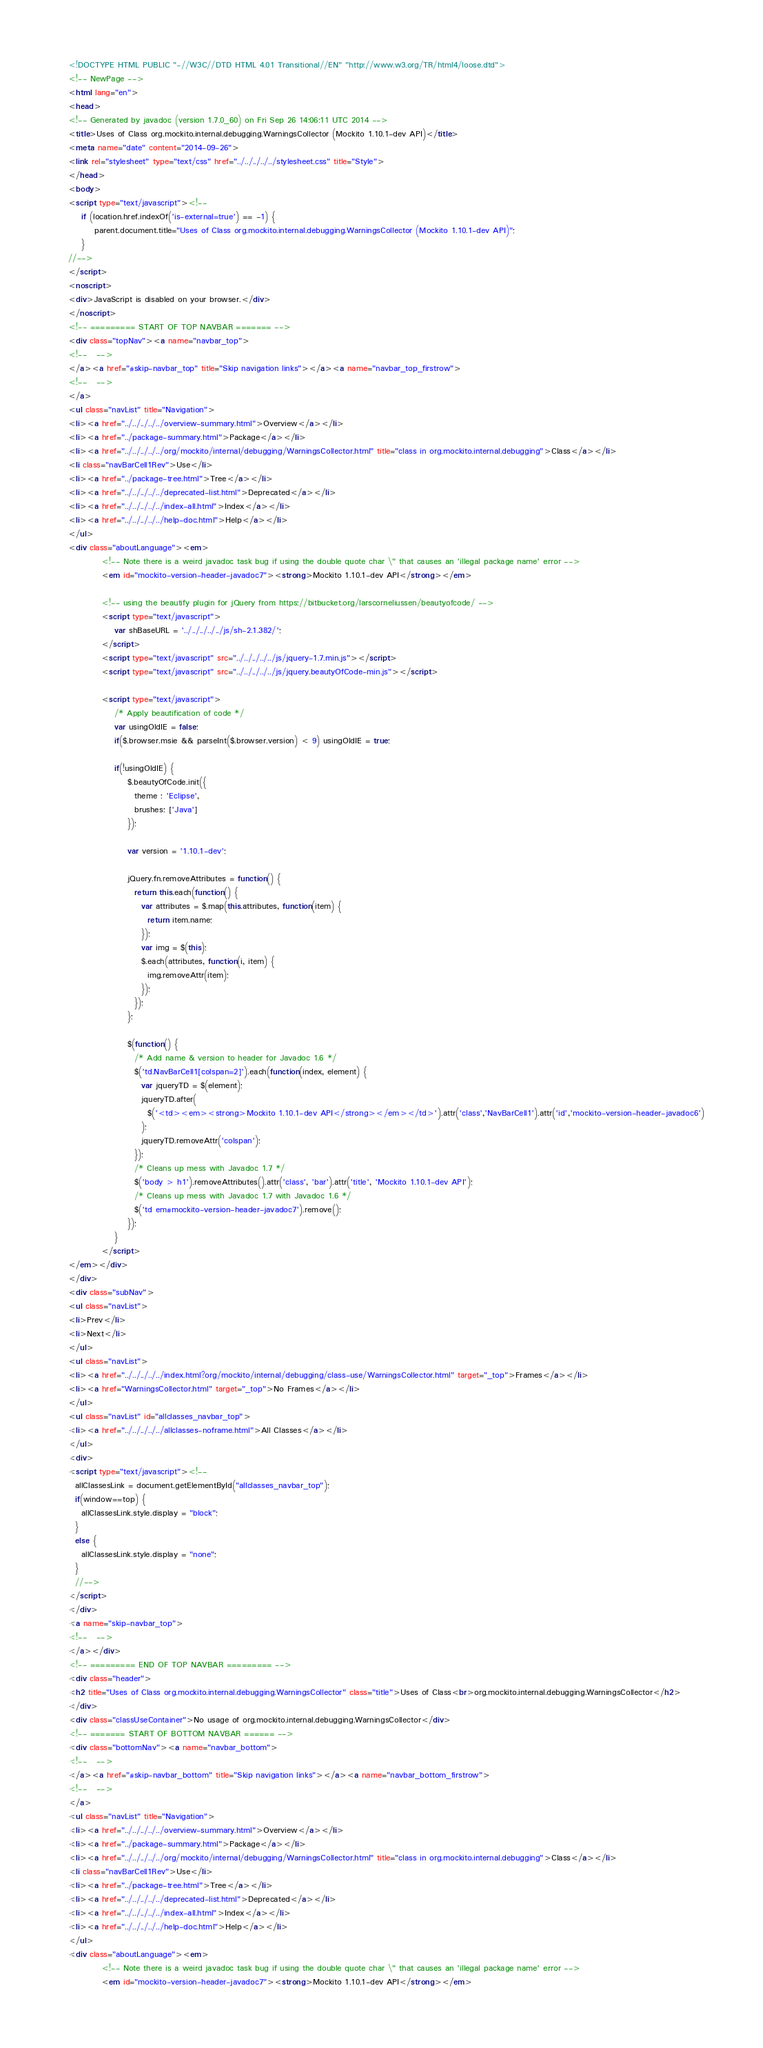Convert code to text. <code><loc_0><loc_0><loc_500><loc_500><_HTML_><!DOCTYPE HTML PUBLIC "-//W3C//DTD HTML 4.01 Transitional//EN" "http://www.w3.org/TR/html4/loose.dtd">
<!-- NewPage -->
<html lang="en">
<head>
<!-- Generated by javadoc (version 1.7.0_60) on Fri Sep 26 14:06:11 UTC 2014 -->
<title>Uses of Class org.mockito.internal.debugging.WarningsCollector (Mockito 1.10.1-dev API)</title>
<meta name="date" content="2014-09-26">
<link rel="stylesheet" type="text/css" href="../../../../../stylesheet.css" title="Style">
</head>
<body>
<script type="text/javascript"><!--
    if (location.href.indexOf('is-external=true') == -1) {
        parent.document.title="Uses of Class org.mockito.internal.debugging.WarningsCollector (Mockito 1.10.1-dev API)";
    }
//-->
</script>
<noscript>
<div>JavaScript is disabled on your browser.</div>
</noscript>
<!-- ========= START OF TOP NAVBAR ======= -->
<div class="topNav"><a name="navbar_top">
<!--   -->
</a><a href="#skip-navbar_top" title="Skip navigation links"></a><a name="navbar_top_firstrow">
<!--   -->
</a>
<ul class="navList" title="Navigation">
<li><a href="../../../../../overview-summary.html">Overview</a></li>
<li><a href="../package-summary.html">Package</a></li>
<li><a href="../../../../../org/mockito/internal/debugging/WarningsCollector.html" title="class in org.mockito.internal.debugging">Class</a></li>
<li class="navBarCell1Rev">Use</li>
<li><a href="../package-tree.html">Tree</a></li>
<li><a href="../../../../../deprecated-list.html">Deprecated</a></li>
<li><a href="../../../../../index-all.html">Index</a></li>
<li><a href="../../../../../help-doc.html">Help</a></li>
</ul>
<div class="aboutLanguage"><em>
          <!-- Note there is a weird javadoc task bug if using the double quote char \" that causes an 'illegal package name' error -->
          <em id="mockito-version-header-javadoc7"><strong>Mockito 1.10.1-dev API</strong></em>

          <!-- using the beautify plugin for jQuery from https://bitbucket.org/larscorneliussen/beautyofcode/ -->
          <script type="text/javascript">
              var shBaseURL = '../../../../../js/sh-2.1.382/';
          </script>
          <script type="text/javascript" src="../../../../../js/jquery-1.7.min.js"></script>
          <script type="text/javascript" src="../../../../../js/jquery.beautyOfCode-min.js"></script>

          <script type="text/javascript">
              /* Apply beautification of code */
              var usingOldIE = false;
              if($.browser.msie && parseInt($.browser.version) < 9) usingOldIE = true;

              if(!usingOldIE) {
                  $.beautyOfCode.init({
                    theme : 'Eclipse',
                    brushes: ['Java']
                  });

                  var version = '1.10.1-dev';

                  jQuery.fn.removeAttributes = function() {
                    return this.each(function() {
                      var attributes = $.map(this.attributes, function(item) {
                        return item.name;
                      });
                      var img = $(this);
                      $.each(attributes, function(i, item) {
                        img.removeAttr(item);
                      });
                    });
                  };

                  $(function() {
                    /* Add name & version to header for Javadoc 1.6 */
                    $('td.NavBarCell1[colspan=2]').each(function(index, element) {
                      var jqueryTD = $(element);
                      jqueryTD.after(
                        $('<td><em><strong>Mockito 1.10.1-dev API</strong></em></td>').attr('class','NavBarCell1').attr('id','mockito-version-header-javadoc6')
                      );
                      jqueryTD.removeAttr('colspan');
                    });
                    /* Cleans up mess with Javadoc 1.7 */
                    $('body > h1').removeAttributes().attr('class', 'bar').attr('title', 'Mockito 1.10.1-dev API');
                    /* Cleans up mess with Javadoc 1.7 with Javadoc 1.6 */
                    $('td em#mockito-version-header-javadoc7').remove();
                  });
              }
          </script>
</em></div>
</div>
<div class="subNav">
<ul class="navList">
<li>Prev</li>
<li>Next</li>
</ul>
<ul class="navList">
<li><a href="../../../../../index.html?org/mockito/internal/debugging/class-use/WarningsCollector.html" target="_top">Frames</a></li>
<li><a href="WarningsCollector.html" target="_top">No Frames</a></li>
</ul>
<ul class="navList" id="allclasses_navbar_top">
<li><a href="../../../../../allclasses-noframe.html">All Classes</a></li>
</ul>
<div>
<script type="text/javascript"><!--
  allClassesLink = document.getElementById("allclasses_navbar_top");
  if(window==top) {
    allClassesLink.style.display = "block";
  }
  else {
    allClassesLink.style.display = "none";
  }
  //-->
</script>
</div>
<a name="skip-navbar_top">
<!--   -->
</a></div>
<!-- ========= END OF TOP NAVBAR ========= -->
<div class="header">
<h2 title="Uses of Class org.mockito.internal.debugging.WarningsCollector" class="title">Uses of Class<br>org.mockito.internal.debugging.WarningsCollector</h2>
</div>
<div class="classUseContainer">No usage of org.mockito.internal.debugging.WarningsCollector</div>
<!-- ======= START OF BOTTOM NAVBAR ====== -->
<div class="bottomNav"><a name="navbar_bottom">
<!--   -->
</a><a href="#skip-navbar_bottom" title="Skip navigation links"></a><a name="navbar_bottom_firstrow">
<!--   -->
</a>
<ul class="navList" title="Navigation">
<li><a href="../../../../../overview-summary.html">Overview</a></li>
<li><a href="../package-summary.html">Package</a></li>
<li><a href="../../../../../org/mockito/internal/debugging/WarningsCollector.html" title="class in org.mockito.internal.debugging">Class</a></li>
<li class="navBarCell1Rev">Use</li>
<li><a href="../package-tree.html">Tree</a></li>
<li><a href="../../../../../deprecated-list.html">Deprecated</a></li>
<li><a href="../../../../../index-all.html">Index</a></li>
<li><a href="../../../../../help-doc.html">Help</a></li>
</ul>
<div class="aboutLanguage"><em>
          <!-- Note there is a weird javadoc task bug if using the double quote char \" that causes an 'illegal package name' error -->
          <em id="mockito-version-header-javadoc7"><strong>Mockito 1.10.1-dev API</strong></em>
</code> 